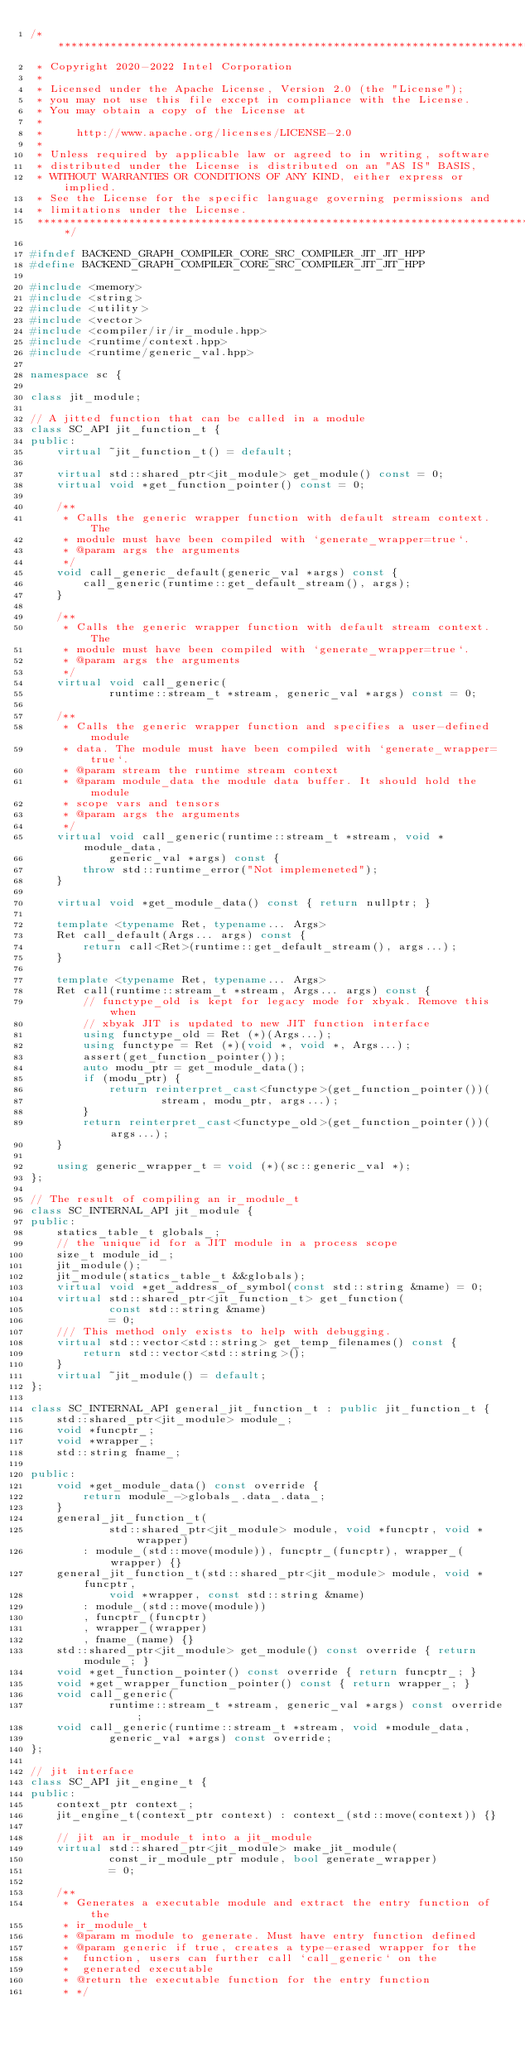Convert code to text. <code><loc_0><loc_0><loc_500><loc_500><_C++_>/*******************************************************************************
 * Copyright 2020-2022 Intel Corporation
 *
 * Licensed under the Apache License, Version 2.0 (the "License");
 * you may not use this file except in compliance with the License.
 * You may obtain a copy of the License at
 *
 *     http://www.apache.org/licenses/LICENSE-2.0
 *
 * Unless required by applicable law or agreed to in writing, software
 * distributed under the License is distributed on an "AS IS" BASIS,
 * WITHOUT WARRANTIES OR CONDITIONS OF ANY KIND, either express or implied.
 * See the License for the specific language governing permissions and
 * limitations under the License.
 *******************************************************************************/

#ifndef BACKEND_GRAPH_COMPILER_CORE_SRC_COMPILER_JIT_JIT_HPP
#define BACKEND_GRAPH_COMPILER_CORE_SRC_COMPILER_JIT_JIT_HPP

#include <memory>
#include <string>
#include <utility>
#include <vector>
#include <compiler/ir/ir_module.hpp>
#include <runtime/context.hpp>
#include <runtime/generic_val.hpp>

namespace sc {

class jit_module;

// A jitted function that can be called in a module
class SC_API jit_function_t {
public:
    virtual ~jit_function_t() = default;

    virtual std::shared_ptr<jit_module> get_module() const = 0;
    virtual void *get_function_pointer() const = 0;

    /**
     * Calls the generic wrapper function with default stream context. The
     * module must have been compiled with `generate_wrapper=true`.
     * @param args the arguments
     */
    void call_generic_default(generic_val *args) const {
        call_generic(runtime::get_default_stream(), args);
    }

    /**
     * Calls the generic wrapper function with default stream context. The
     * module must have been compiled with `generate_wrapper=true`.
     * @param args the arguments
     */
    virtual void call_generic(
            runtime::stream_t *stream, generic_val *args) const = 0;

    /**
     * Calls the generic wrapper function and specifies a user-defined module
     * data. The module must have been compiled with `generate_wrapper=true`.
     * @param stream the runtime stream context
     * @param module_data the module data buffer. It should hold the module
     * scope vars and tensors
     * @param args the arguments
     */
    virtual void call_generic(runtime::stream_t *stream, void *module_data,
            generic_val *args) const {
        throw std::runtime_error("Not implemeneted");
    }

    virtual void *get_module_data() const { return nullptr; }

    template <typename Ret, typename... Args>
    Ret call_default(Args... args) const {
        return call<Ret>(runtime::get_default_stream(), args...);
    }

    template <typename Ret, typename... Args>
    Ret call(runtime::stream_t *stream, Args... args) const {
        // functype_old is kept for legacy mode for xbyak. Remove this when
        // xbyak JIT is updated to new JIT function interface
        using functype_old = Ret (*)(Args...);
        using functype = Ret (*)(void *, void *, Args...);
        assert(get_function_pointer());
        auto modu_ptr = get_module_data();
        if (modu_ptr) {
            return reinterpret_cast<functype>(get_function_pointer())(
                    stream, modu_ptr, args...);
        }
        return reinterpret_cast<functype_old>(get_function_pointer())(args...);
    }

    using generic_wrapper_t = void (*)(sc::generic_val *);
};

// The result of compiling an ir_module_t
class SC_INTERNAL_API jit_module {
public:
    statics_table_t globals_;
    // the unique id for a JIT module in a process scope
    size_t module_id_;
    jit_module();
    jit_module(statics_table_t &&globals);
    virtual void *get_address_of_symbol(const std::string &name) = 0;
    virtual std::shared_ptr<jit_function_t> get_function(
            const std::string &name)
            = 0;
    /// This method only exists to help with debugging.
    virtual std::vector<std::string> get_temp_filenames() const {
        return std::vector<std::string>();
    }
    virtual ~jit_module() = default;
};

class SC_INTERNAL_API general_jit_function_t : public jit_function_t {
    std::shared_ptr<jit_module> module_;
    void *funcptr_;
    void *wrapper_;
    std::string fname_;

public:
    void *get_module_data() const override {
        return module_->globals_.data_.data_;
    }
    general_jit_function_t(
            std::shared_ptr<jit_module> module, void *funcptr, void *wrapper)
        : module_(std::move(module)), funcptr_(funcptr), wrapper_(wrapper) {}
    general_jit_function_t(std::shared_ptr<jit_module> module, void *funcptr,
            void *wrapper, const std::string &name)
        : module_(std::move(module))
        , funcptr_(funcptr)
        , wrapper_(wrapper)
        , fname_(name) {}
    std::shared_ptr<jit_module> get_module() const override { return module_; }
    void *get_function_pointer() const override { return funcptr_; }
    void *get_wrapper_function_pointer() const { return wrapper_; }
    void call_generic(
            runtime::stream_t *stream, generic_val *args) const override;
    void call_generic(runtime::stream_t *stream, void *module_data,
            generic_val *args) const override;
};

// jit interface
class SC_API jit_engine_t {
public:
    context_ptr context_;
    jit_engine_t(context_ptr context) : context_(std::move(context)) {}

    // jit an ir_module_t into a jit_module
    virtual std::shared_ptr<jit_module> make_jit_module(
            const_ir_module_ptr module, bool generate_wrapper)
            = 0;

    /**
     * Generates a executable module and extract the entry function of the
     * ir_module_t
     * @param m module to generate. Must have entry function defined
     * @param generic if true, creates a type-erased wrapper for the
     *  function, users can further call `call_generic` on the
     *  generated executable
     * @return the executable function for the entry function
     * */</code> 